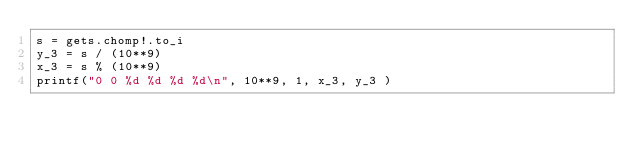Convert code to text. <code><loc_0><loc_0><loc_500><loc_500><_Ruby_>s = gets.chomp!.to_i
y_3 = s / (10**9)
x_3 = s % (10**9)
printf("0 0 %d %d %d %d\n", 10**9, 1, x_3, y_3 )</code> 